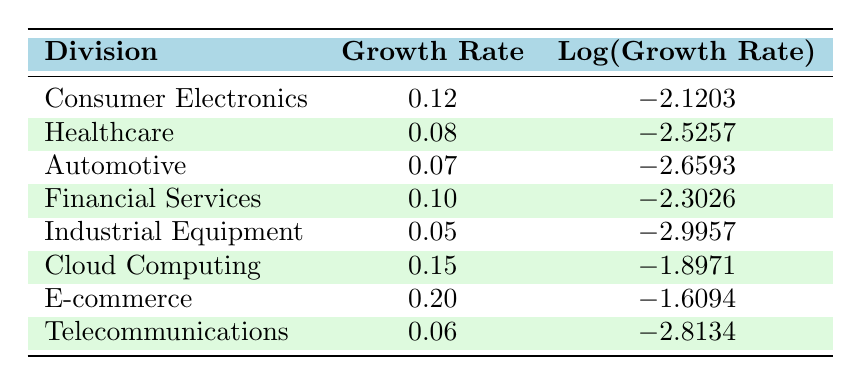What is the annual revenue growth rate of the Cloud Computing division? By looking at the table, we can see that the growth rate for the Cloud Computing division is listed directly under the "Growth Rate" column.
Answer: 0.15 Which division has the lowest annual revenue growth rate? The table shows various growth rates, and comparing them, we find that the Industrial Equipment division has the lowest growth rate of 0.05.
Answer: Industrial Equipment What is the logarithmic value corresponding to the annual revenue growth rate of E-commerce? The table lists the logarithmic value of the growth rate for E-commerce under the "Log(Growth Rate)" column, which shows -1.6094.
Answer: -1.6094 Is the annual revenue growth rate of the Automotive division greater than that of the Telecommunications division? By comparing the growth rates, we see that Automotive has a growth rate of 0.07 and Telecommunications has 0.06. Since 0.07 is greater than 0.06, the statement is true.
Answer: Yes What is the average annual revenue growth rate of all divisions listed? To find the average, we add all the growth rates: (0.12 + 0.08 + 0.07 + 0.10 + 0.05 + 0.15 + 0.20 + 0.06) = 0.83, then divide by the number of divisions, which is 8: 0.83 / 8 = 0.10375. Therefore, the average growth rate is approximately 0.104.
Answer: 0.104 Which division has a growth rate greater than both Healthcare and Automotive? Healthcare has a growth rate of 0.08 and Automotive has 0.07. Among the divisions, only Cloud Computing (0.15) and E-commerce (0.20) have growth rates higher than both of these.
Answer: Cloud Computing and E-commerce Is there any division with a growth rate of 0.1 or higher? By checking the growth rates listed, we find Consumer Electronics (0.12), Financial Services (0.10), Cloud Computing (0.15), and E-commerce (0.20) all meet this criterion. Thus, the answer is true.
Answer: Yes What is the difference between the highest and the lowest growth rates among the divisions? The highest growth rate is E-commerce at 0.20 and the lowest is Industrial Equipment at 0.05. The difference is calculated as 0.20 - 0.05 = 0.15.
Answer: 0.15 Which divisions have a logarithmic growth value less than -2.5? By examining the logarithmic values in the table, we see that the divisions with values less than -2.5 are Healthcare (-2.5257), Automotive (-2.6593), Industrial Equipment (-2.9957), and Telecommunications (-2.8134).
Answer: Healthcare, Automotive, Industrial Equipment, Telecommunications 